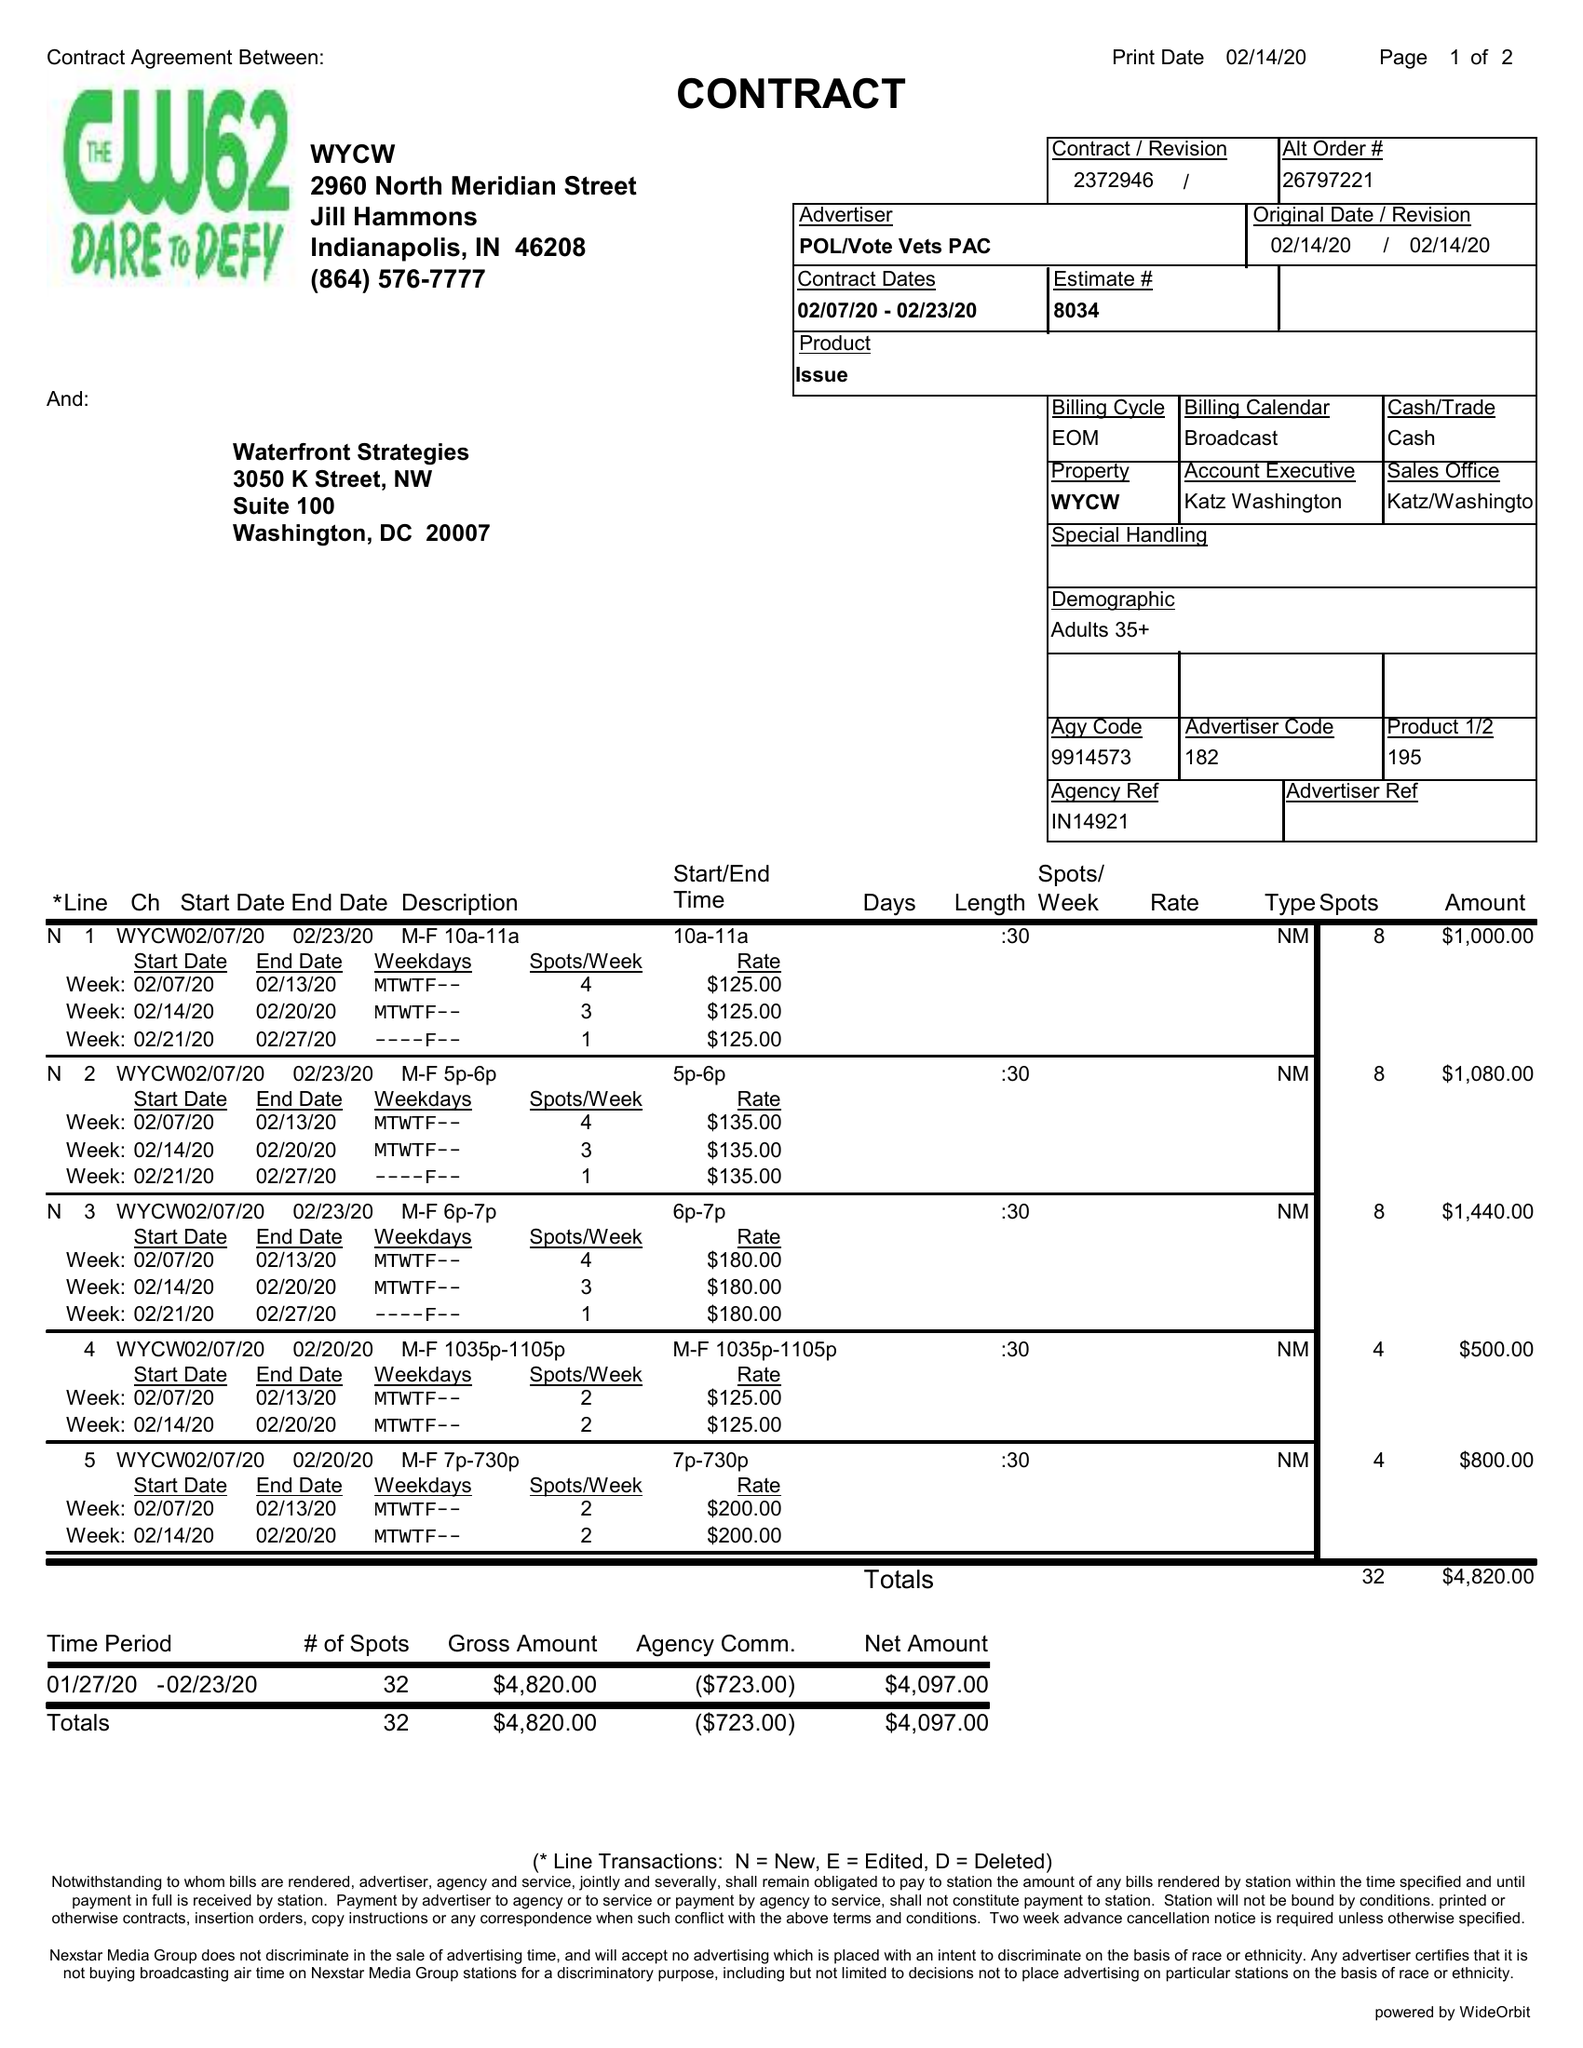What is the value for the flight_to?
Answer the question using a single word or phrase. 02/23/20 